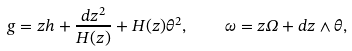Convert formula to latex. <formula><loc_0><loc_0><loc_500><loc_500>g = z h + \frac { d z ^ { 2 } } { H ( z ) } + H ( z ) \theta ^ { 2 } , \quad \omega = z \Omega + d z \wedge \theta ,</formula> 